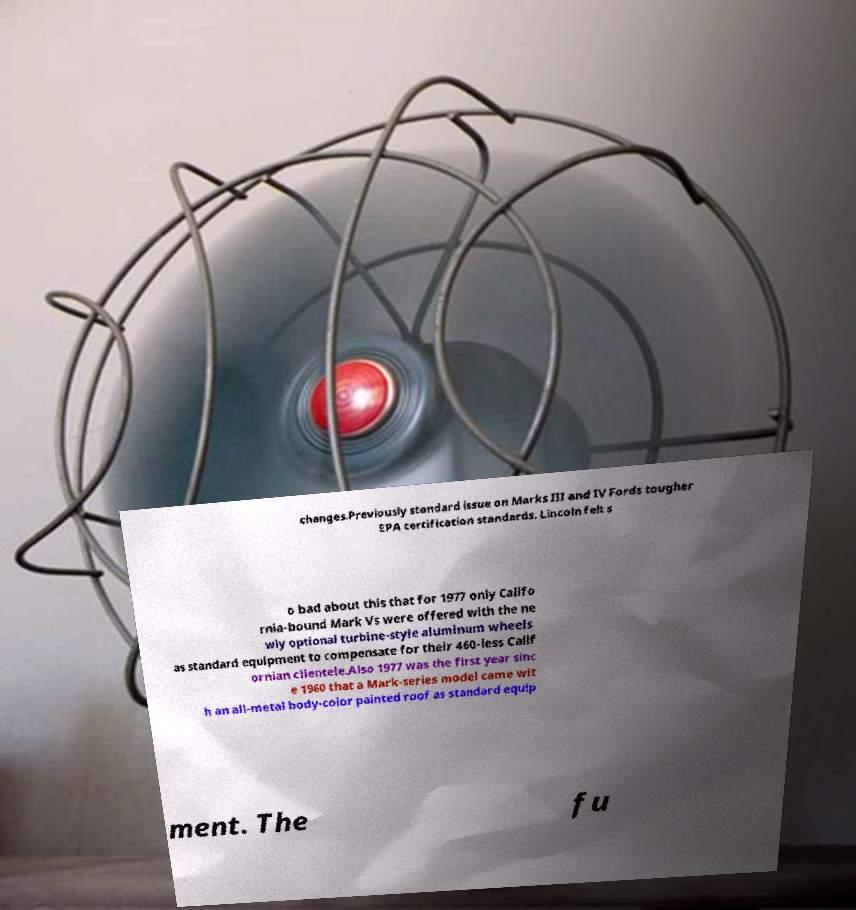There's text embedded in this image that I need extracted. Can you transcribe it verbatim? changes.Previously standard issue on Marks III and IV Fords tougher EPA certification standards. Lincoln felt s o bad about this that for 1977 only Califo rnia-bound Mark Vs were offered with the ne wly optional turbine-style aluminum wheels as standard equipment to compensate for their 460-less Calif ornian clientele.Also 1977 was the first year sinc e 1960 that a Mark-series model came wit h an all-metal body-color painted roof as standard equip ment. The fu 